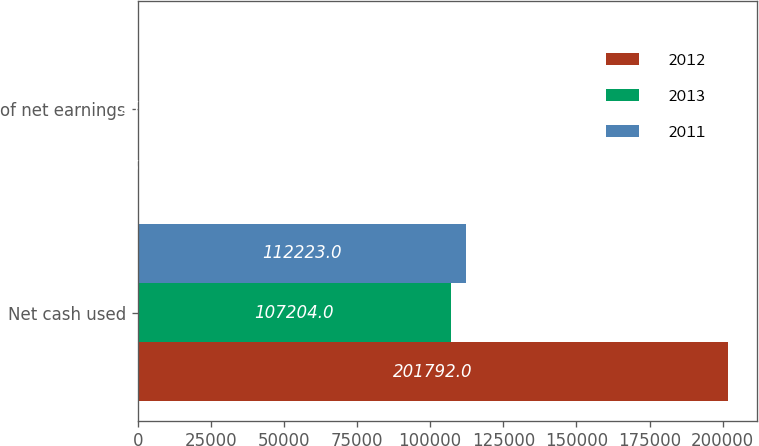Convert chart to OTSL. <chart><loc_0><loc_0><loc_500><loc_500><stacked_bar_chart><ecel><fcel>Net cash used<fcel>of net earnings<nl><fcel>2012<fcel>201792<fcel>45<nl><fcel>2013<fcel>107204<fcel>25.5<nl><fcel>2011<fcel>112223<fcel>31.4<nl></chart> 